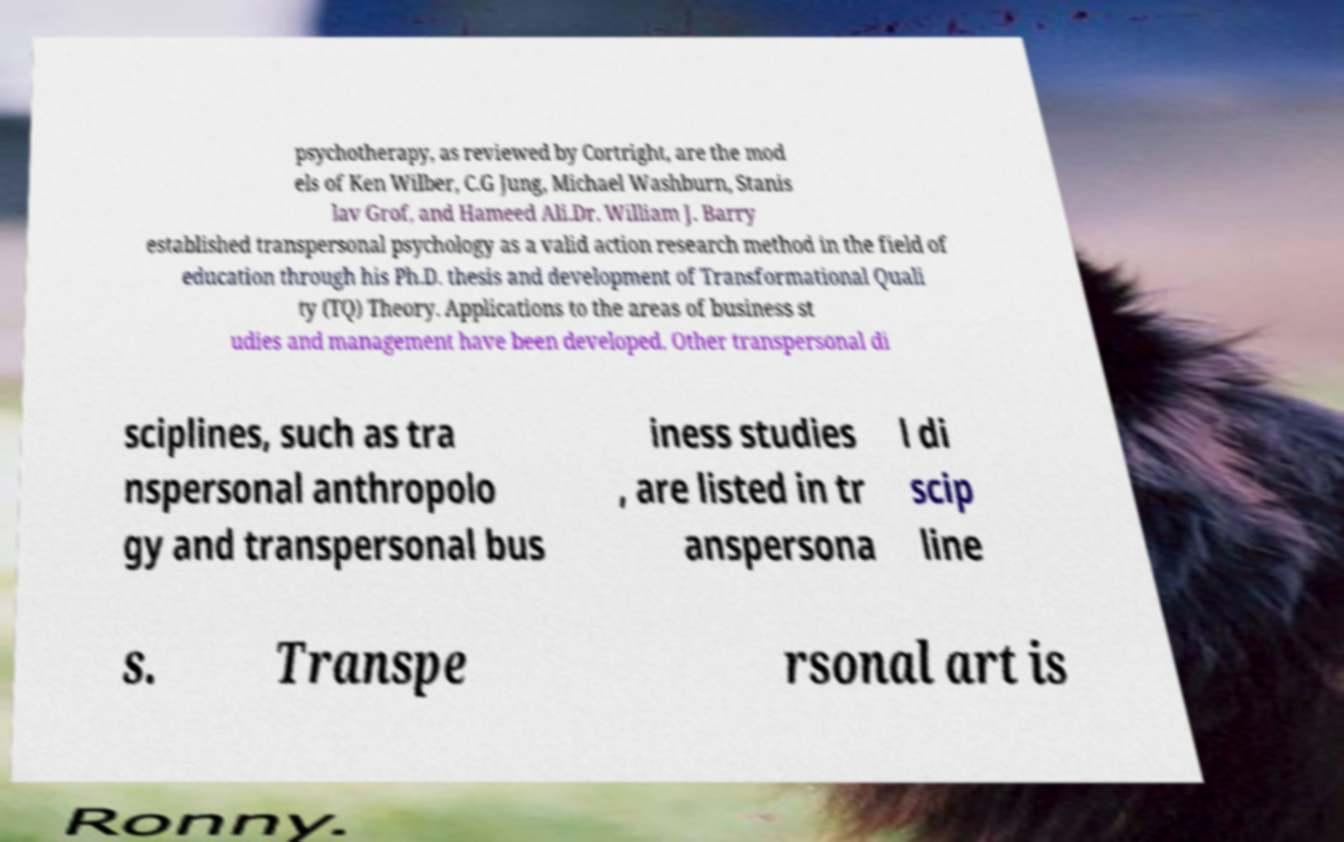Can you read and provide the text displayed in the image?This photo seems to have some interesting text. Can you extract and type it out for me? psychotherapy, as reviewed by Cortright, are the mod els of Ken Wilber, C.G Jung, Michael Washburn, Stanis lav Grof, and Hameed Ali.Dr. William J. Barry established transpersonal psychology as a valid action research method in the field of education through his Ph.D. thesis and development of Transformational Quali ty (TQ) Theory. Applications to the areas of business st udies and management have been developed. Other transpersonal di sciplines, such as tra nspersonal anthropolo gy and transpersonal bus iness studies , are listed in tr anspersona l di scip line s. Transpe rsonal art is 